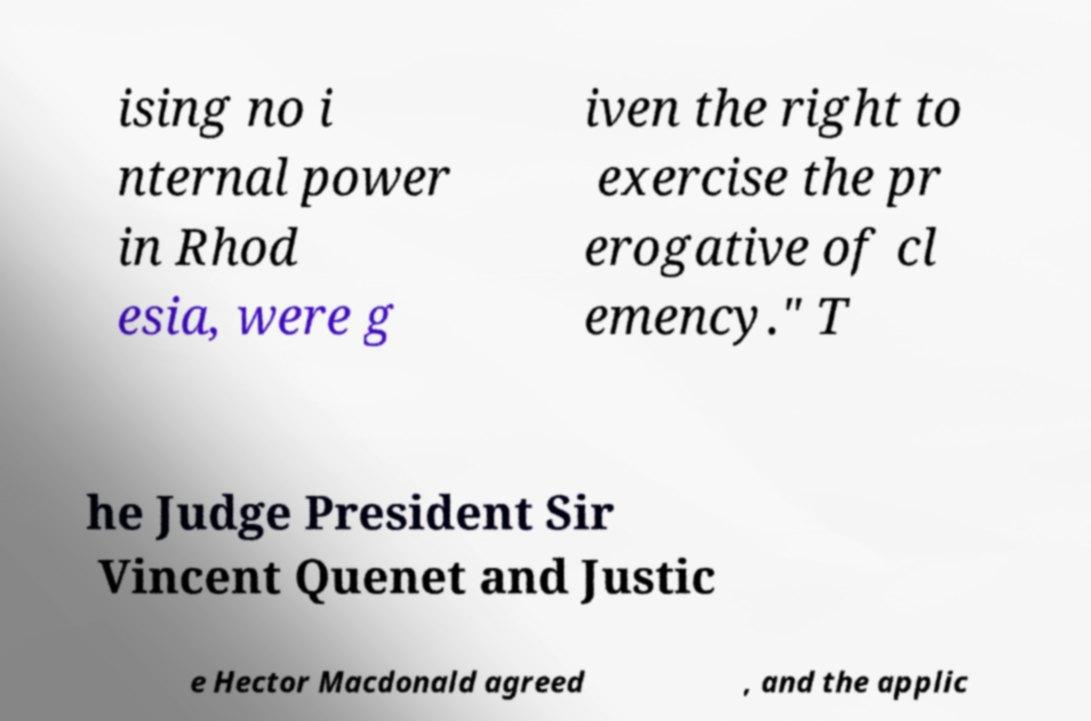Please read and relay the text visible in this image. What does it say? ising no i nternal power in Rhod esia, were g iven the right to exercise the pr erogative of cl emency." T he Judge President Sir Vincent Quenet and Justic e Hector Macdonald agreed , and the applic 